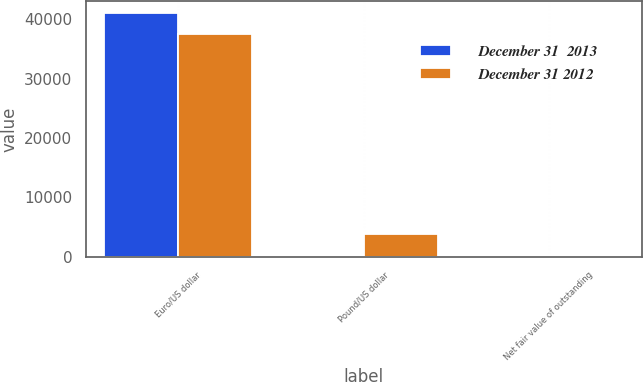<chart> <loc_0><loc_0><loc_500><loc_500><stacked_bar_chart><ecel><fcel>Euro/US dollar<fcel>Pound/US dollar<fcel>Net fair value of outstanding<nl><fcel>December 31  2013<fcel>41021<fcel>0<fcel>33<nl><fcel>December 31 2012<fcel>37598<fcel>3810<fcel>18<nl></chart> 